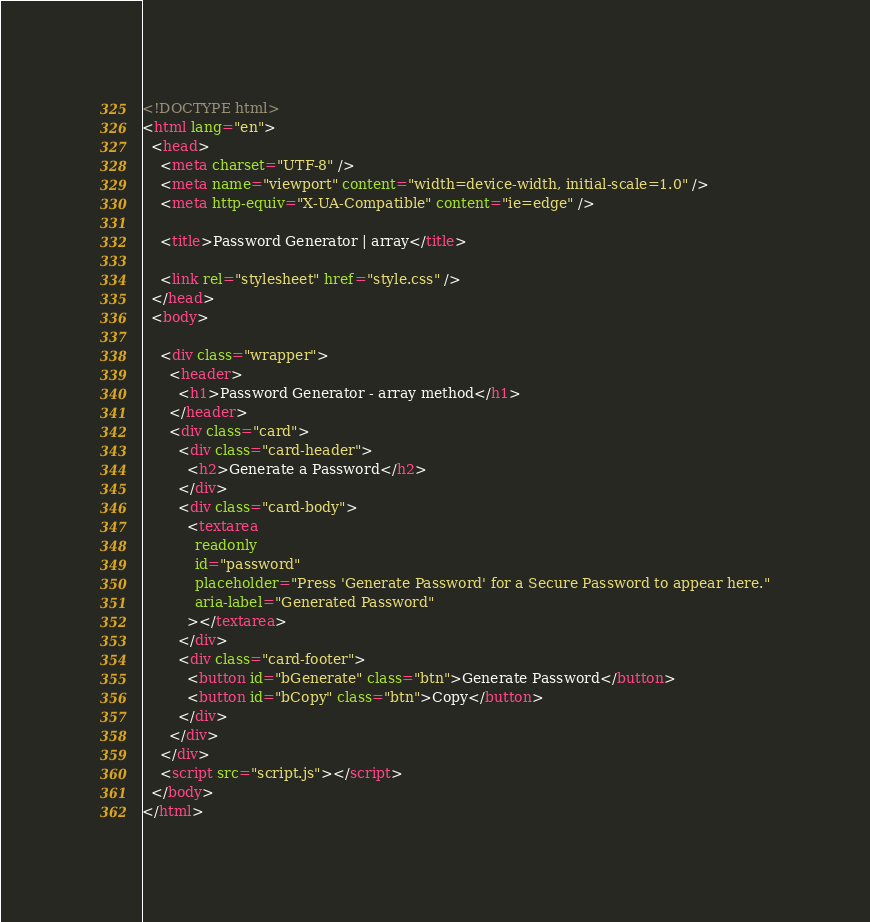<code> <loc_0><loc_0><loc_500><loc_500><_HTML_><!DOCTYPE html>
<html lang="en">
  <head>
    <meta charset="UTF-8" />
    <meta name="viewport" content="width=device-width, initial-scale=1.0" />
    <meta http-equiv="X-UA-Compatible" content="ie=edge" />

    <title>Password Generator | array</title>

    <link rel="stylesheet" href="style.css" />
  </head>
  <body>

    <div class="wrapper">
      <header>
        <h1>Password Generator - array method</h1>
      </header>
      <div class="card">
        <div class="card-header">
          <h2>Generate a Password</h2>
        </div>
        <div class="card-body">
          <textarea
            readonly
            id="password"
            placeholder="Press 'Generate Password' for a Secure Password to appear here."
            aria-label="Generated Password"
          ></textarea>
        </div>
        <div class="card-footer">
          <button id="bGenerate" class="btn">Generate Password</button>
          <button id="bCopy" class="btn">Copy</button>
        </div>
      </div>
    </div>
    <script src="script.js"></script>
  </body>
</html>
</code> 